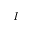Convert formula to latex. <formula><loc_0><loc_0><loc_500><loc_500>I</formula> 